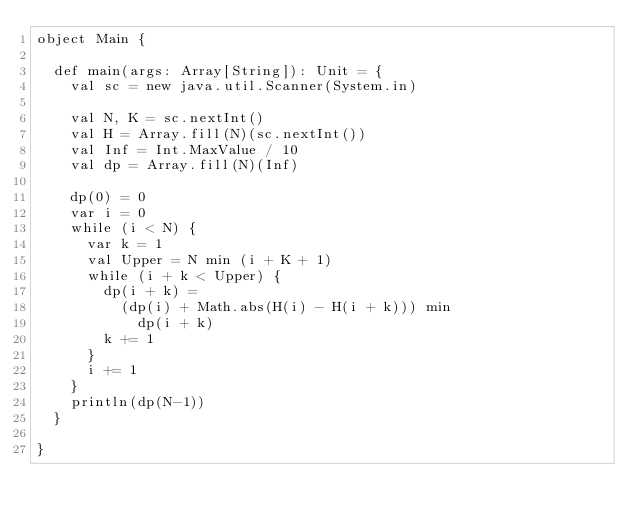Convert code to text. <code><loc_0><loc_0><loc_500><loc_500><_Scala_>object Main {

  def main(args: Array[String]): Unit = {
    val sc = new java.util.Scanner(System.in)

    val N, K = sc.nextInt()
    val H = Array.fill(N)(sc.nextInt())
    val Inf = Int.MaxValue / 10
    val dp = Array.fill(N)(Inf)

    dp(0) = 0
    var i = 0
    while (i < N) {
      var k = 1
      val Upper = N min (i + K + 1)
      while (i + k < Upper) {
        dp(i + k) =
          (dp(i) + Math.abs(H(i) - H(i + k))) min
            dp(i + k)
        k += 1
      }
      i += 1
    }
    println(dp(N-1))
  }

}</code> 